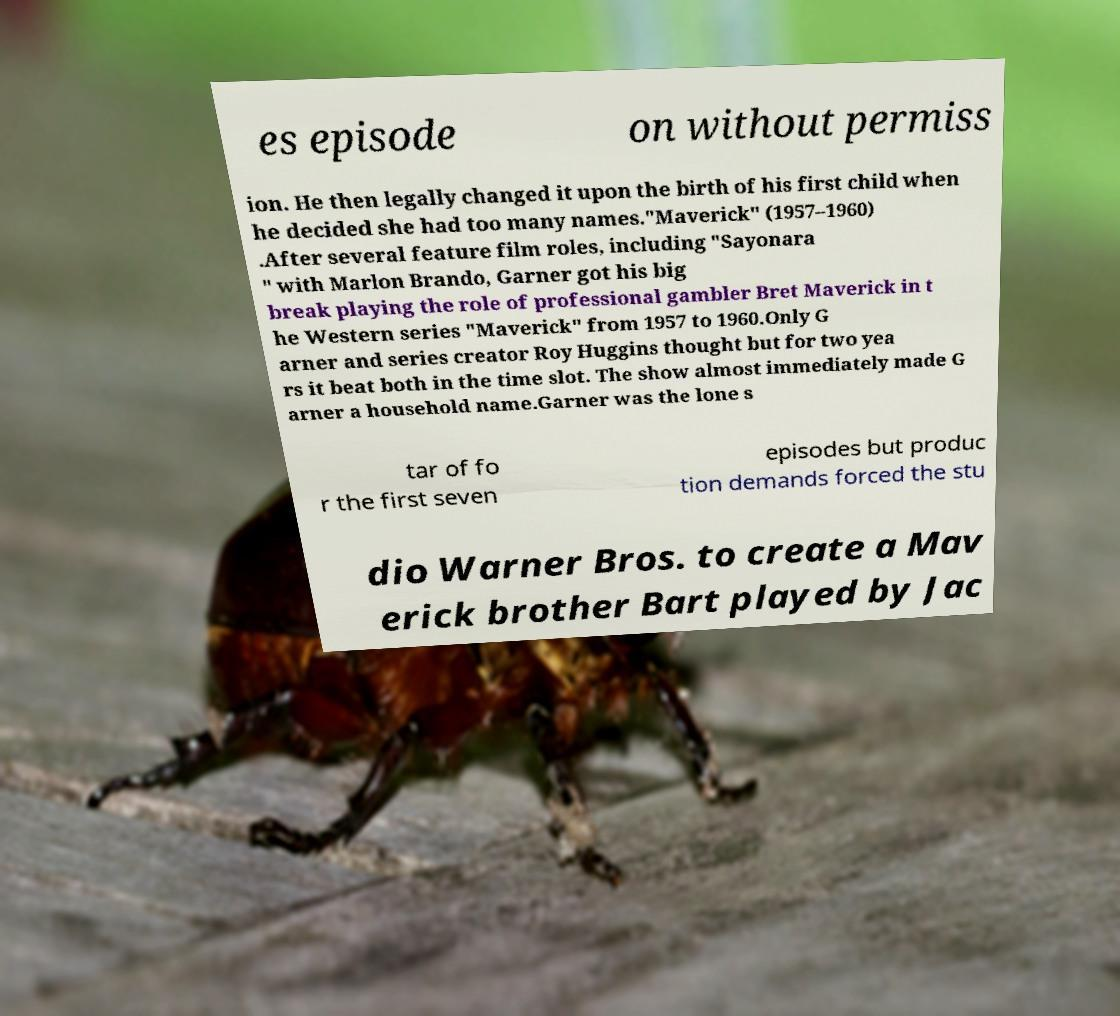I need the written content from this picture converted into text. Can you do that? es episode on without permiss ion. He then legally changed it upon the birth of his first child when he decided she had too many names."Maverick" (1957–1960) .After several feature film roles, including "Sayonara " with Marlon Brando, Garner got his big break playing the role of professional gambler Bret Maverick in t he Western series "Maverick" from 1957 to 1960.Only G arner and series creator Roy Huggins thought but for two yea rs it beat both in the time slot. The show almost immediately made G arner a household name.Garner was the lone s tar of fo r the first seven episodes but produc tion demands forced the stu dio Warner Bros. to create a Mav erick brother Bart played by Jac 